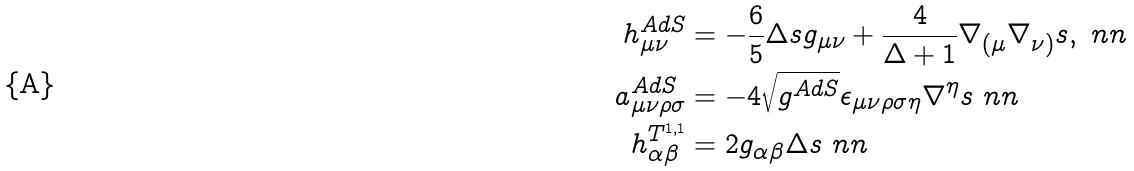Convert formula to latex. <formula><loc_0><loc_0><loc_500><loc_500>h _ { \mu \nu } ^ { A d S } & = - \frac { 6 } { 5 } \Delta s g _ { \mu \nu } + \frac { 4 } { \Delta + 1 } \nabla _ { ( \mu } \nabla _ { \nu ) } s , \ n n \\ a _ { \mu \nu \rho \sigma } ^ { A d S } & = - 4 \sqrt { g ^ { A d S } } \epsilon _ { \mu \nu \rho \sigma \eta } \nabla ^ { \eta } s \ n n \\ h _ { \alpha \beta } ^ { T ^ { 1 , 1 } } & = 2 g _ { \alpha \beta } \Delta s \ n n</formula> 